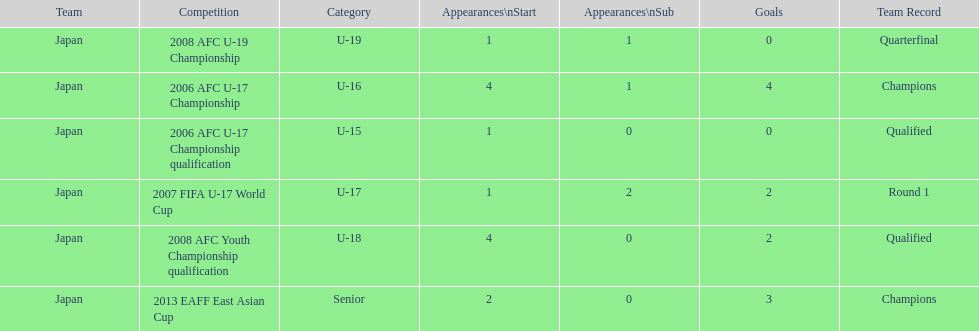Which competitions had champions team records? 2006 AFC U-17 Championship, 2013 EAFF East Asian Cup. Of these competitions, which one was in the senior category? 2013 EAFF East Asian Cup. 